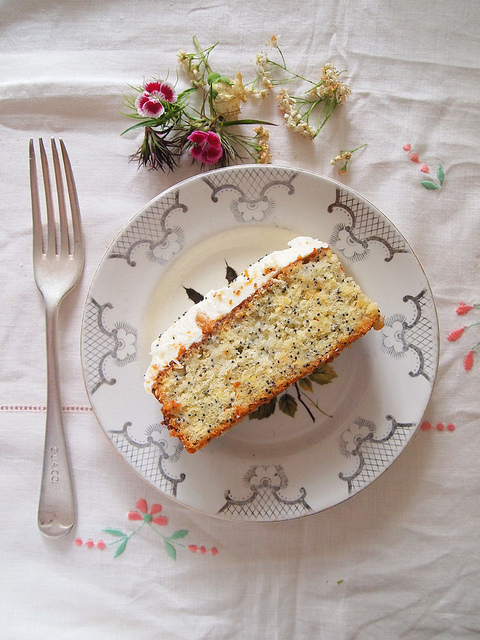Is there anything else on the plate apart from the cake? The plate solely features the slice of cake, emphasizing its prominence as the central element of this delightful serving. 